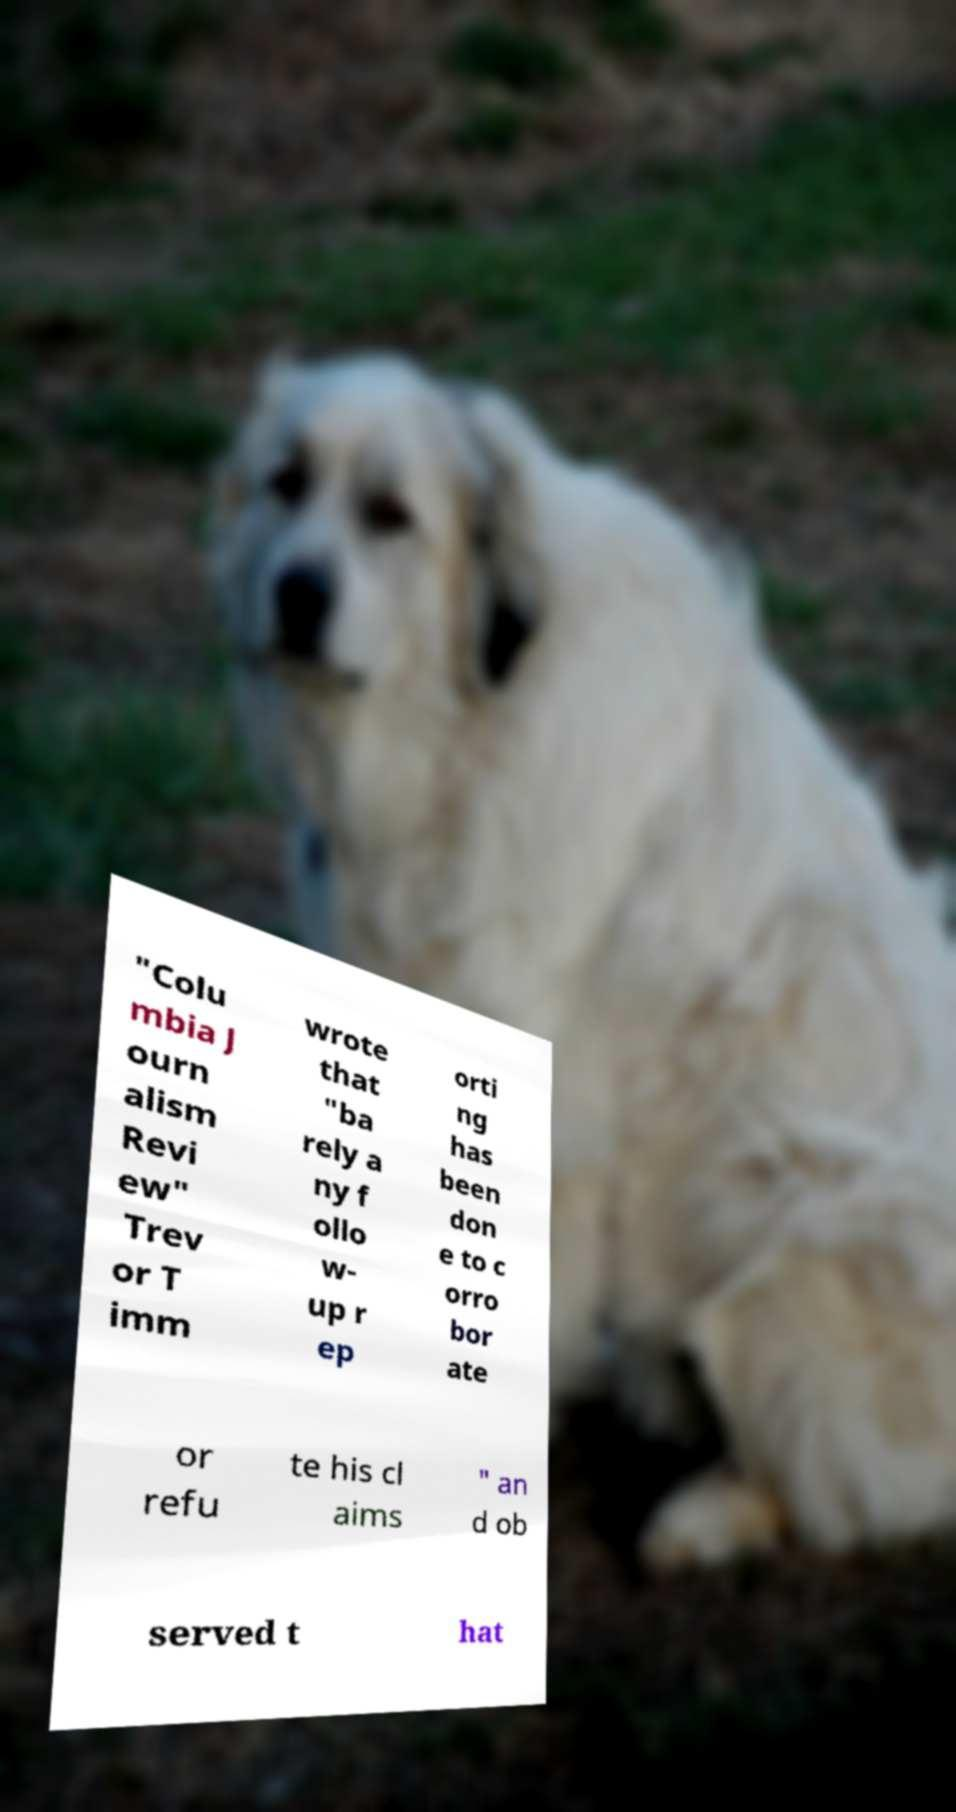Could you extract and type out the text from this image? "Colu mbia J ourn alism Revi ew" Trev or T imm wrote that "ba rely a ny f ollo w- up r ep orti ng has been don e to c orro bor ate or refu te his cl aims " an d ob served t hat 